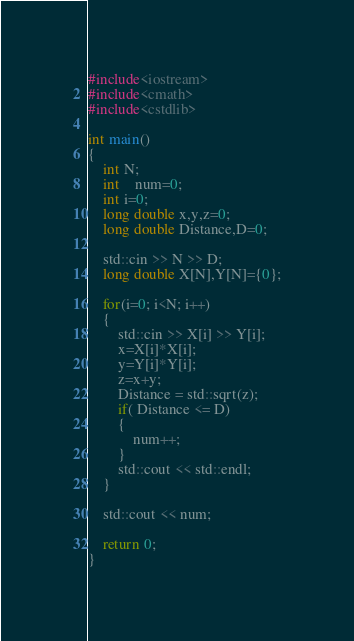<code> <loc_0><loc_0><loc_500><loc_500><_C++_>#include<iostream>
#include<cmath>
#include<cstdlib>

int main()
{
    int N;
  	int	num=0;
    int i=0;
    long double x,y,z=0;
    long double Distance,D=0;

    std::cin >> N >> D;
    long double X[N],Y[N]={0};

    for(i=0; i<N; i++)
    {
        std::cin >> X[i] >> Y[i];
        x=X[i]*X[i];
        y=Y[i]*Y[i];
        z=x+y;
        Distance = std::sqrt(z);
        if( Distance <= D)
        {
            num++;
        }
        std::cout << std::endl;
    }
  
    std::cout << num;

    return 0;
}</code> 